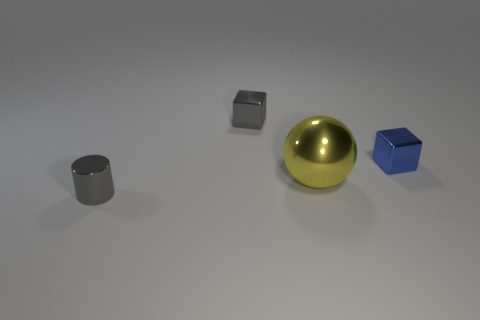Is the color of the cube that is left of the large yellow metal ball the same as the cylinder?
Make the answer very short. Yes. Are there any small shiny things of the same color as the tiny cylinder?
Give a very brief answer. Yes. The other small metallic object that is the same shape as the small blue object is what color?
Provide a succinct answer. Gray. There is a shiny block left of the blue block; is its color the same as the tiny object in front of the large yellow metallic ball?
Your answer should be very brief. Yes. What is the color of the cylinder?
Provide a succinct answer. Gray. Is there anything else that has the same color as the large object?
Keep it short and to the point. No. What is the color of the shiny object that is behind the yellow object and left of the blue block?
Offer a terse response. Gray. There is a gray thing that is right of the gray metal cylinder; is it the same size as the yellow shiny thing?
Ensure brevity in your answer.  No. Are there more tiny gray things to the right of the small gray shiny cylinder than yellow rubber objects?
Offer a terse response. Yes. Is the shape of the yellow thing the same as the small blue thing?
Offer a terse response. No. 